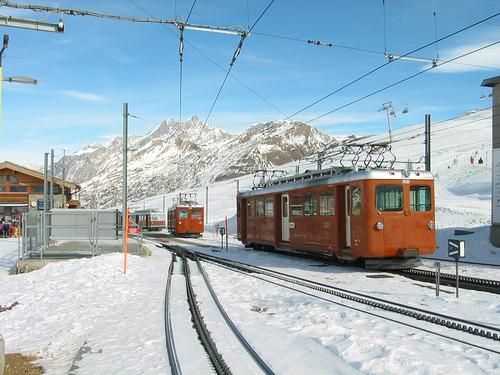What is ropeway called? Please explain your reasoning. aerial tramway. This tram is above the ground with cables hanging over it in sky. 